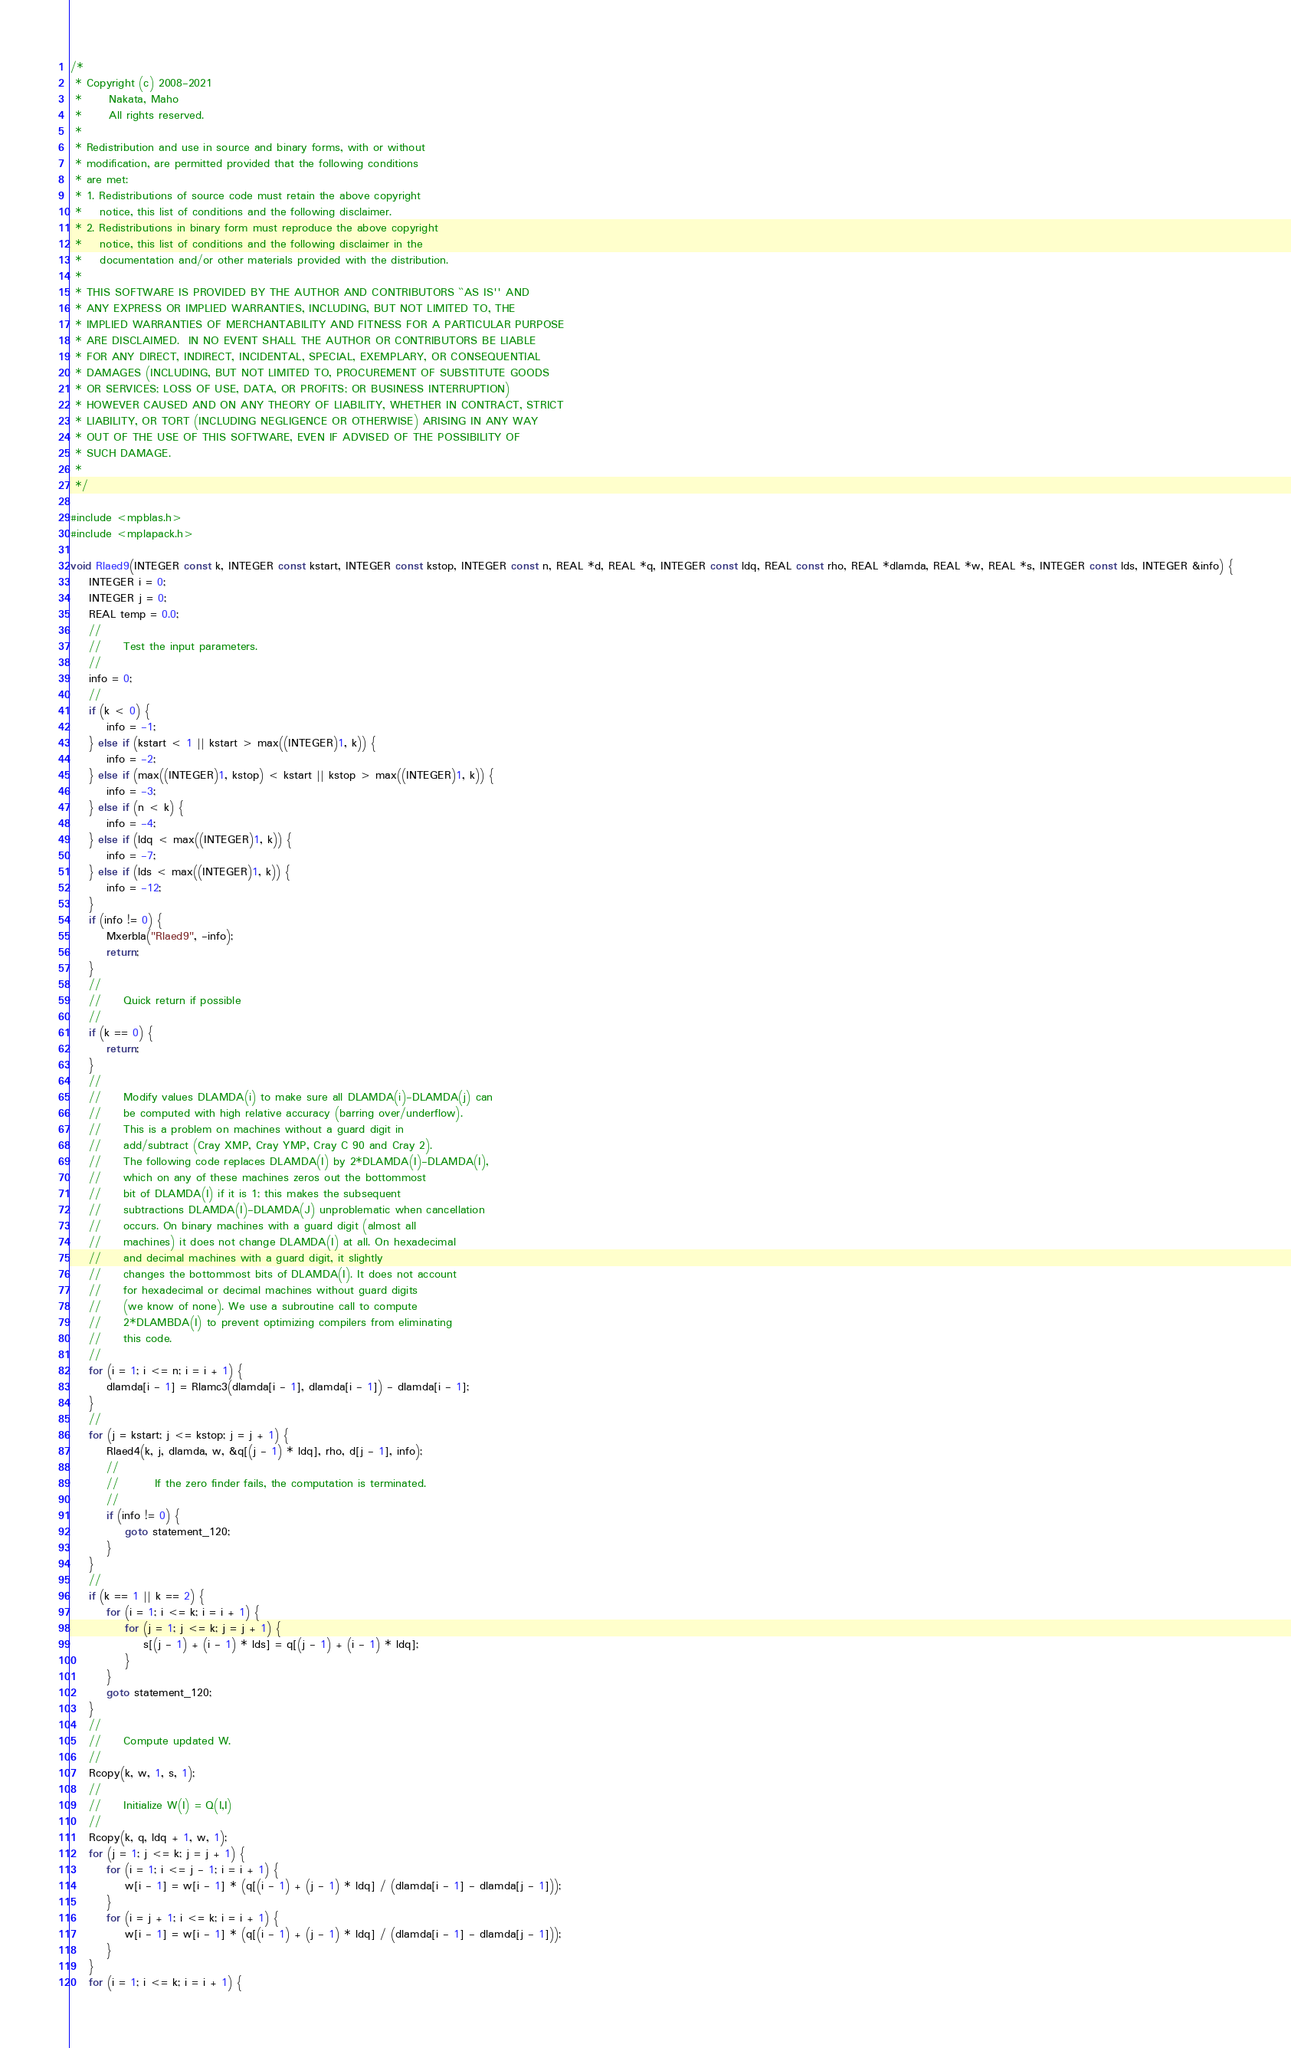Convert code to text. <code><loc_0><loc_0><loc_500><loc_500><_C++_>/*
 * Copyright (c) 2008-2021
 *      Nakata, Maho
 *      All rights reserved.
 *
 * Redistribution and use in source and binary forms, with or without
 * modification, are permitted provided that the following conditions
 * are met:
 * 1. Redistributions of source code must retain the above copyright
 *    notice, this list of conditions and the following disclaimer.
 * 2. Redistributions in binary form must reproduce the above copyright
 *    notice, this list of conditions and the following disclaimer in the
 *    documentation and/or other materials provided with the distribution.
 *
 * THIS SOFTWARE IS PROVIDED BY THE AUTHOR AND CONTRIBUTORS ``AS IS'' AND
 * ANY EXPRESS OR IMPLIED WARRANTIES, INCLUDING, BUT NOT LIMITED TO, THE
 * IMPLIED WARRANTIES OF MERCHANTABILITY AND FITNESS FOR A PARTICULAR PURPOSE
 * ARE DISCLAIMED.  IN NO EVENT SHALL THE AUTHOR OR CONTRIBUTORS BE LIABLE
 * FOR ANY DIRECT, INDIRECT, INCIDENTAL, SPECIAL, EXEMPLARY, OR CONSEQUENTIAL
 * DAMAGES (INCLUDING, BUT NOT LIMITED TO, PROCUREMENT OF SUBSTITUTE GOODS
 * OR SERVICES; LOSS OF USE, DATA, OR PROFITS; OR BUSINESS INTERRUPTION)
 * HOWEVER CAUSED AND ON ANY THEORY OF LIABILITY, WHETHER IN CONTRACT, STRICT
 * LIABILITY, OR TORT (INCLUDING NEGLIGENCE OR OTHERWISE) ARISING IN ANY WAY
 * OUT OF THE USE OF THIS SOFTWARE, EVEN IF ADVISED OF THE POSSIBILITY OF
 * SUCH DAMAGE.
 *
 */

#include <mpblas.h>
#include <mplapack.h>

void Rlaed9(INTEGER const k, INTEGER const kstart, INTEGER const kstop, INTEGER const n, REAL *d, REAL *q, INTEGER const ldq, REAL const rho, REAL *dlamda, REAL *w, REAL *s, INTEGER const lds, INTEGER &info) {
    INTEGER i = 0;
    INTEGER j = 0;
    REAL temp = 0.0;
    //
    //     Test the input parameters.
    //
    info = 0;
    //
    if (k < 0) {
        info = -1;
    } else if (kstart < 1 || kstart > max((INTEGER)1, k)) {
        info = -2;
    } else if (max((INTEGER)1, kstop) < kstart || kstop > max((INTEGER)1, k)) {
        info = -3;
    } else if (n < k) {
        info = -4;
    } else if (ldq < max((INTEGER)1, k)) {
        info = -7;
    } else if (lds < max((INTEGER)1, k)) {
        info = -12;
    }
    if (info != 0) {
        Mxerbla("Rlaed9", -info);
        return;
    }
    //
    //     Quick return if possible
    //
    if (k == 0) {
        return;
    }
    //
    //     Modify values DLAMDA(i) to make sure all DLAMDA(i)-DLAMDA(j) can
    //     be computed with high relative accuracy (barring over/underflow).
    //     This is a problem on machines without a guard digit in
    //     add/subtract (Cray XMP, Cray YMP, Cray C 90 and Cray 2).
    //     The following code replaces DLAMDA(I) by 2*DLAMDA(I)-DLAMDA(I),
    //     which on any of these machines zeros out the bottommost
    //     bit of DLAMDA(I) if it is 1; this makes the subsequent
    //     subtractions DLAMDA(I)-DLAMDA(J) unproblematic when cancellation
    //     occurs. On binary machines with a guard digit (almost all
    //     machines) it does not change DLAMDA(I) at all. On hexadecimal
    //     and decimal machines with a guard digit, it slightly
    //     changes the bottommost bits of DLAMDA(I). It does not account
    //     for hexadecimal or decimal machines without guard digits
    //     (we know of none). We use a subroutine call to compute
    //     2*DLAMBDA(I) to prevent optimizing compilers from eliminating
    //     this code.
    //
    for (i = 1; i <= n; i = i + 1) {
        dlamda[i - 1] = Rlamc3(dlamda[i - 1], dlamda[i - 1]) - dlamda[i - 1];
    }
    //
    for (j = kstart; j <= kstop; j = j + 1) {
        Rlaed4(k, j, dlamda, w, &q[(j - 1) * ldq], rho, d[j - 1], info);
        //
        //        If the zero finder fails, the computation is terminated.
        //
        if (info != 0) {
            goto statement_120;
        }
    }
    //
    if (k == 1 || k == 2) {
        for (i = 1; i <= k; i = i + 1) {
            for (j = 1; j <= k; j = j + 1) {
                s[(j - 1) + (i - 1) * lds] = q[(j - 1) + (i - 1) * ldq];
            }
        }
        goto statement_120;
    }
    //
    //     Compute updated W.
    //
    Rcopy(k, w, 1, s, 1);
    //
    //     Initialize W(I) = Q(I,I)
    //
    Rcopy(k, q, ldq + 1, w, 1);
    for (j = 1; j <= k; j = j + 1) {
        for (i = 1; i <= j - 1; i = i + 1) {
            w[i - 1] = w[i - 1] * (q[(i - 1) + (j - 1) * ldq] / (dlamda[i - 1] - dlamda[j - 1]));
        }
        for (i = j + 1; i <= k; i = i + 1) {
            w[i - 1] = w[i - 1] * (q[(i - 1) + (j - 1) * ldq] / (dlamda[i - 1] - dlamda[j - 1]));
        }
    }
    for (i = 1; i <= k; i = i + 1) {</code> 